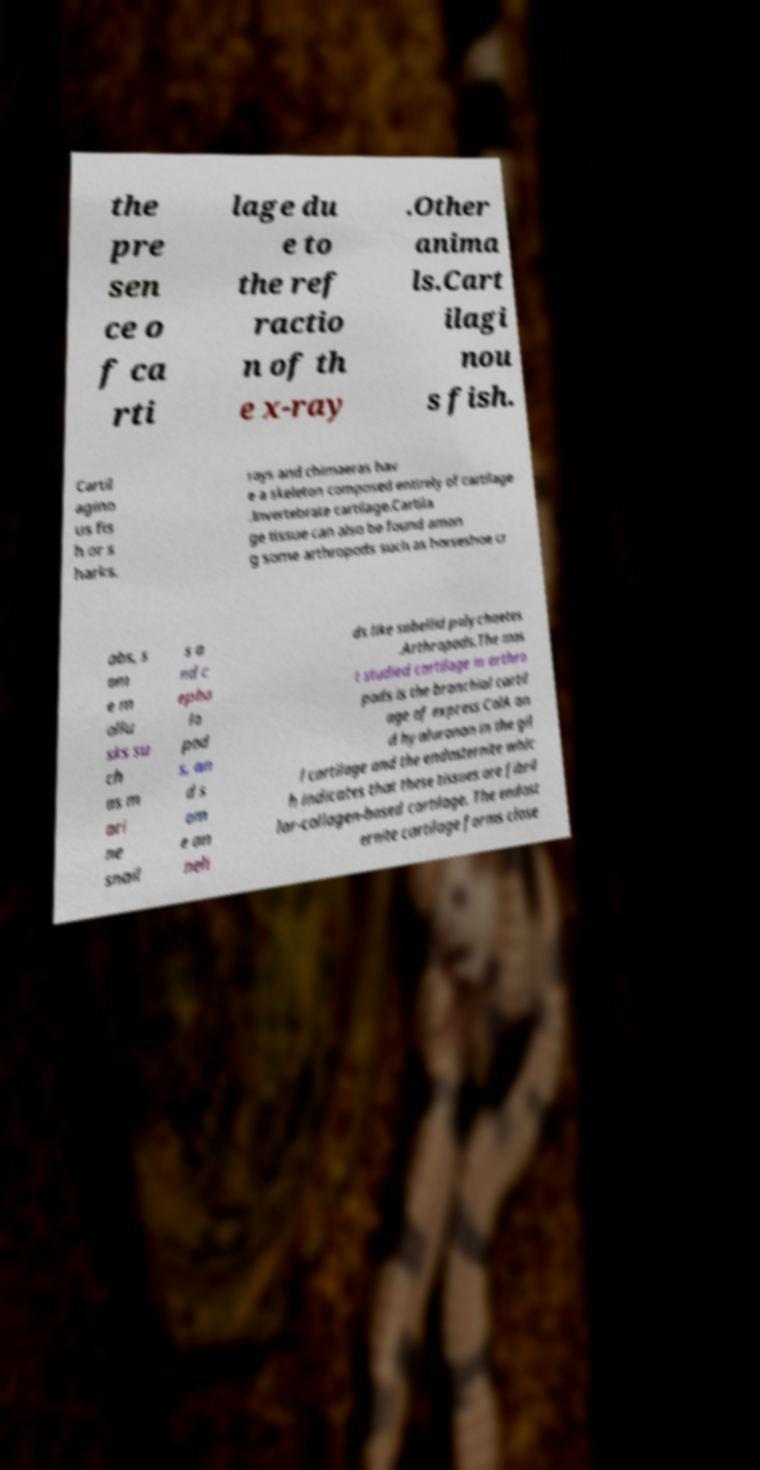Please read and relay the text visible in this image. What does it say? the pre sen ce o f ca rti lage du e to the ref ractio n of th e x-ray .Other anima ls.Cart ilagi nou s fish. Cartil agino us fis h or s harks, rays and chimaeras hav e a skeleton composed entirely of cartilage .Invertebrate cartilage.Cartila ge tissue can also be found amon g some arthropods such as horseshoe cr abs, s om e m ollu sks su ch as m ari ne snail s a nd c epha lo pod s, an d s om e an neli ds like sabellid polychaetes .Arthropods.The mos t studied cartilage in arthro pods is the branchial cartil age of express ColA an d hyaluronan in the gil l cartilage and the endosternite whic h indicates that these tissues are fibril lar-collagen-based cartilage. The endost ernite cartilage forms close 